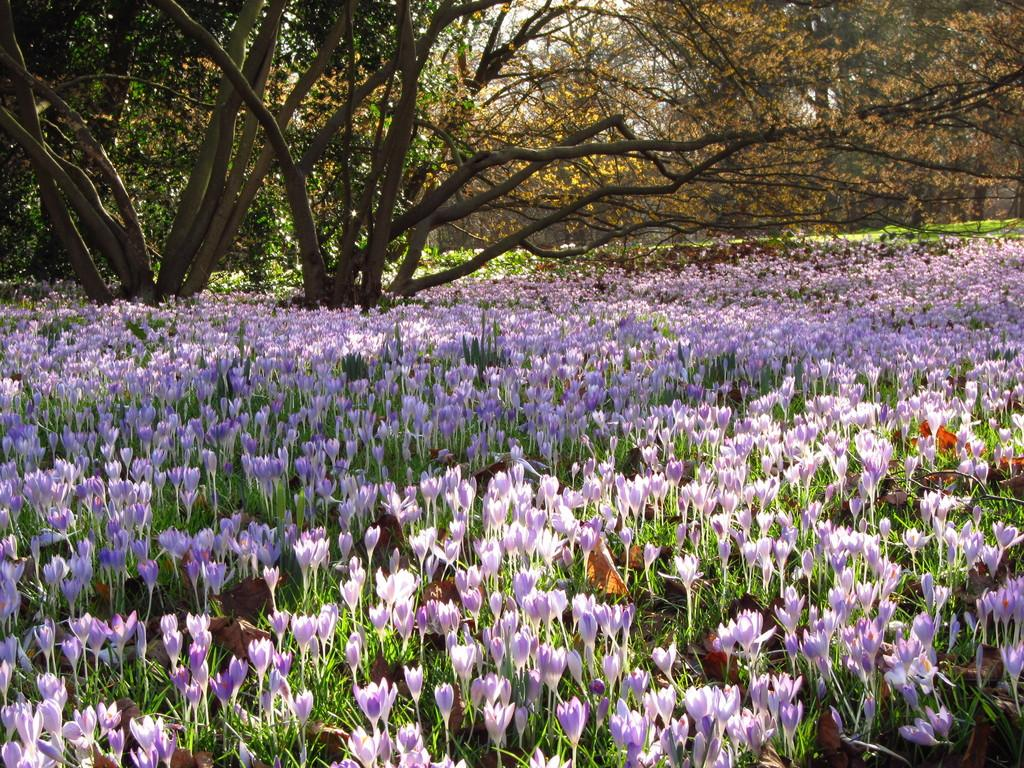What type of vegetation can be seen in the image? There are flowers and plants in the image. How many trees are present between the plants in the image? There are two trees between the plants in the image. What type of liquid is being poured by the stranger in the image? There is no stranger present in the image, and therefore no liquid being poured. 